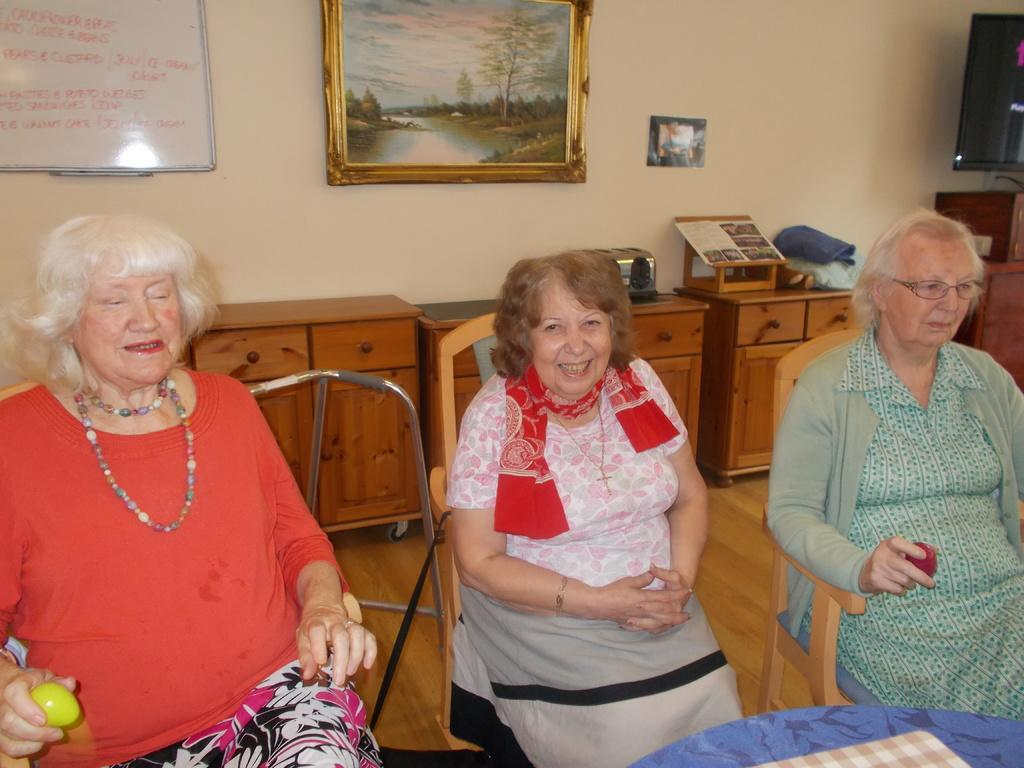How many women are in the image? There are three women in the image. What are the women doing in the image? The women are seated on chairs. What can be seen behind the women? There is a photo frame visible behind the women. What object is present in the image that is typically used for writing or displaying information? There is a whiteboard in the image. What is in front of the women? There is a table in front of the women. Can you see any nests in the image? There are no nests present in the image. Are there any cobwebs visible in the image? There are no cobwebs visible in the image. 